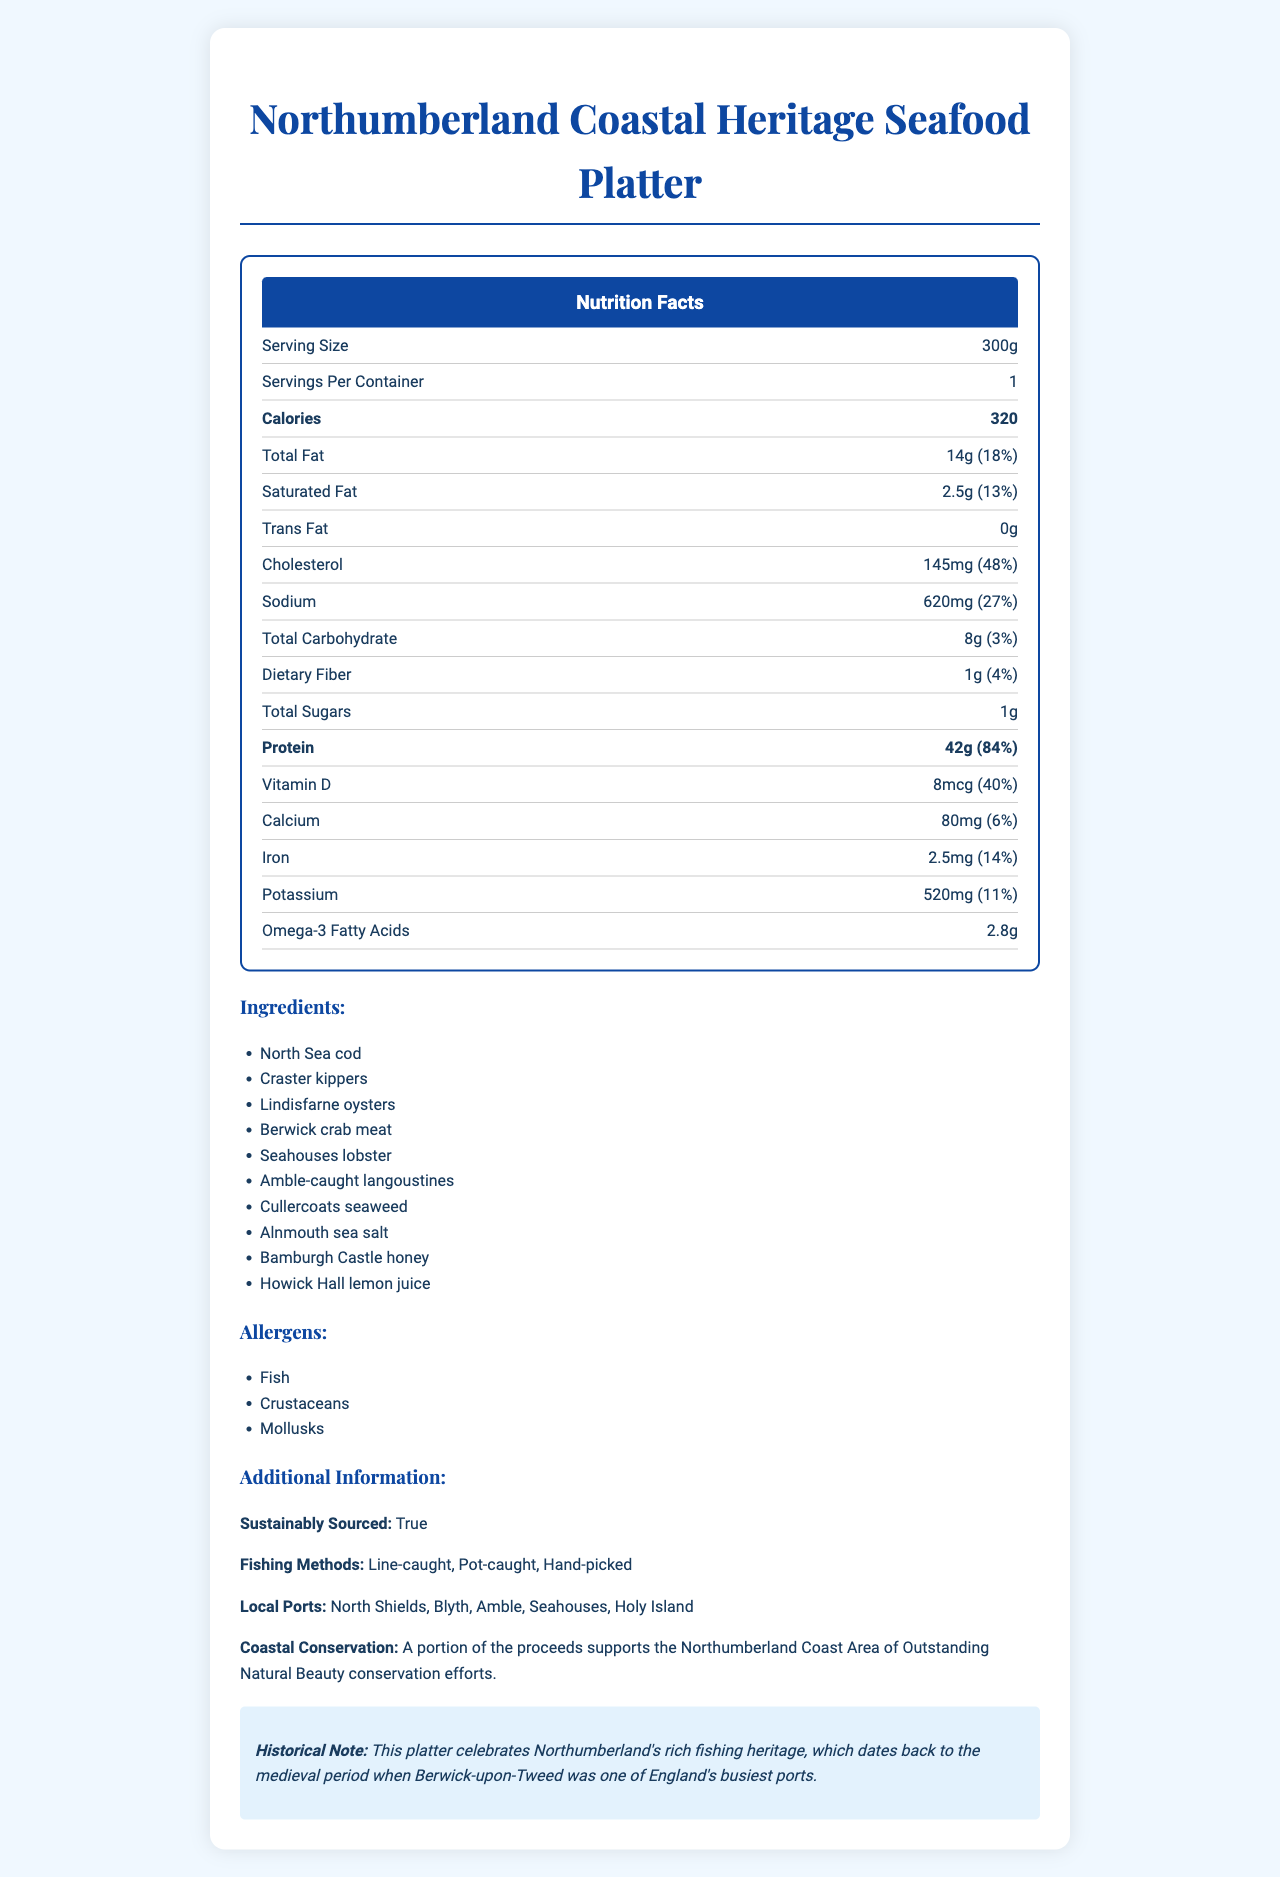what is the serving size? The serving size is directly mentioned under the Nutrition Facts section, noted as "Serving Size: 300g".
Answer: 300g how many servings are in one container? The document states that there is "1 serving per container".
Answer: 1 how many calories are in the platter? The number of calories in the platter is listed as 320.
Answer: 320 what is the percentage of daily value for total fat? The daily value percentage for total fat is given as 18%.
Answer: 18% what are the main ingredients of the platter? The ingredient list is explicitly stated in the document.
Answer: North Sea cod, Craster kippers, Lindisfarne oysters, Berwick crab meat, Seahouses lobster, Amble-caught langoustines, Cullercoats seaweed, Alnmouth sea salt, Bamburgh Castle honey, Howick Hall lemon juice what type of seafood is NOT mentioned in the ingredients? A. Haddock B. Cod C. Lobster Haddock is not mentioned; cod and lobster are listed as ingredients.
Answer: A what portion of the platter supports coastal conservation efforts? A. None B. All C. A portion The document states that a portion of the proceeds supports coastal conservation efforts.
Answer: C is the platter sustainably sourced? The document specifies that the seafood platter is sustainably sourced.
Answer: Yes how much protein is in each serving? The amount of protein per serving is listed as 42g.
Answer: 42g what are the daily values for cholesterol and sodium? The daily values are 48% for cholesterol and 27% for sodium, as stated in the document.
Answer: Cholesterol: 48%, Sodium: 27% what fishing methods are used to source the seafood? The fishing methods are listed as Line-caught, Pot-caught, and Hand-picked.
Answer: Line-caught, Pot-caught, Hand-picked what historical detail is mentioned about the region? The historical note provides this specific detail.
Answer: The document mentions that Northumberland's fishing heritage dates back to the medieval period when Berwick-upon-Tweed was one of England's busiest ports. can we determine the price of the seafood platter from this document? The document provides nutrition facts and historical context but does not mention the price.
Answer: Not enough information summarize the main nutritional highlights and historical significance of the Northumberland Coastal Heritage Seafood Platter. The document provides detailed nutritional information, highlights the local and sustainable sourcing of ingredients, includes a historical note, and mentions conservation efforts related to the product.
Answer: The Northumberland Coastal Heritage Seafood Platter provides 320 calories per 300g serving and is rich in protein (42g), omega-3 fatty acids, and several vitamins and minerals. It includes various locally-sourced seafood ingredients, all sustainably obtained using traditional fishing methods. The platter also celebrates Northumberland's long-standing fishing heritage dating back to medieval times with a portion of proceeds supporting local conservation efforts. 